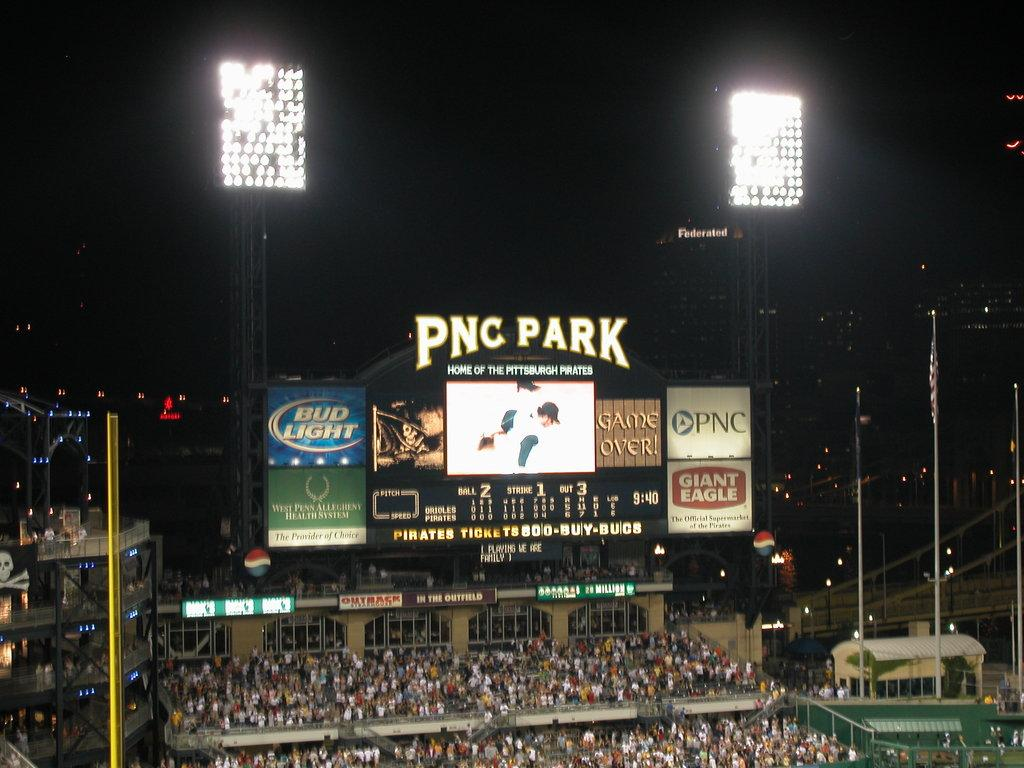<image>
Render a clear and concise summary of the photo. Night ball game being played PNC Park with the stands full 